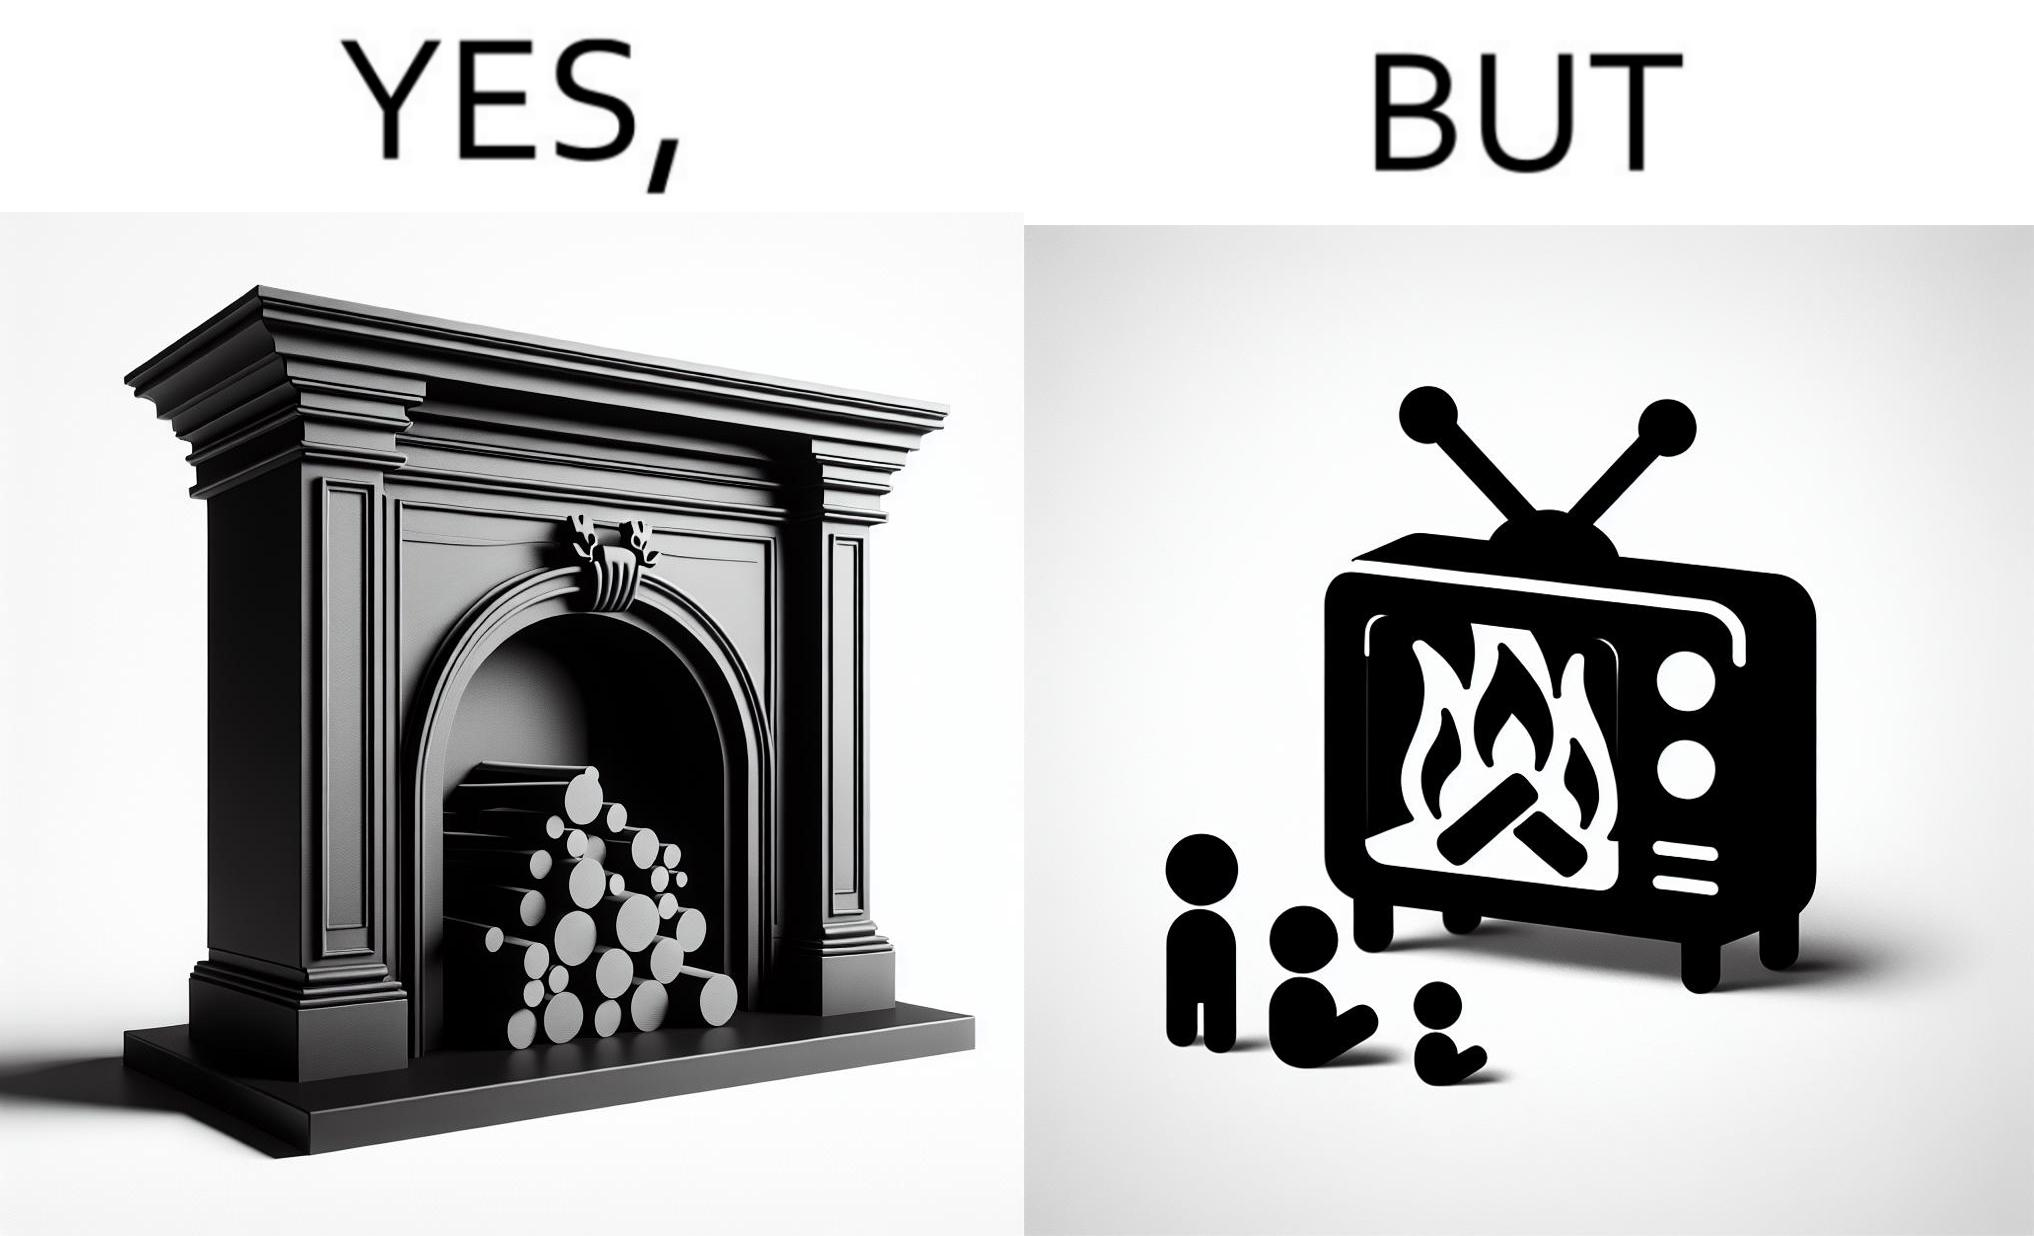Provide a description of this image. The images are funny since they show how even though real fireplaces exist, people choose to be lazy and watch fireplaces on television because they dont want the inconveniences of cleaning up, etc. afterwards 